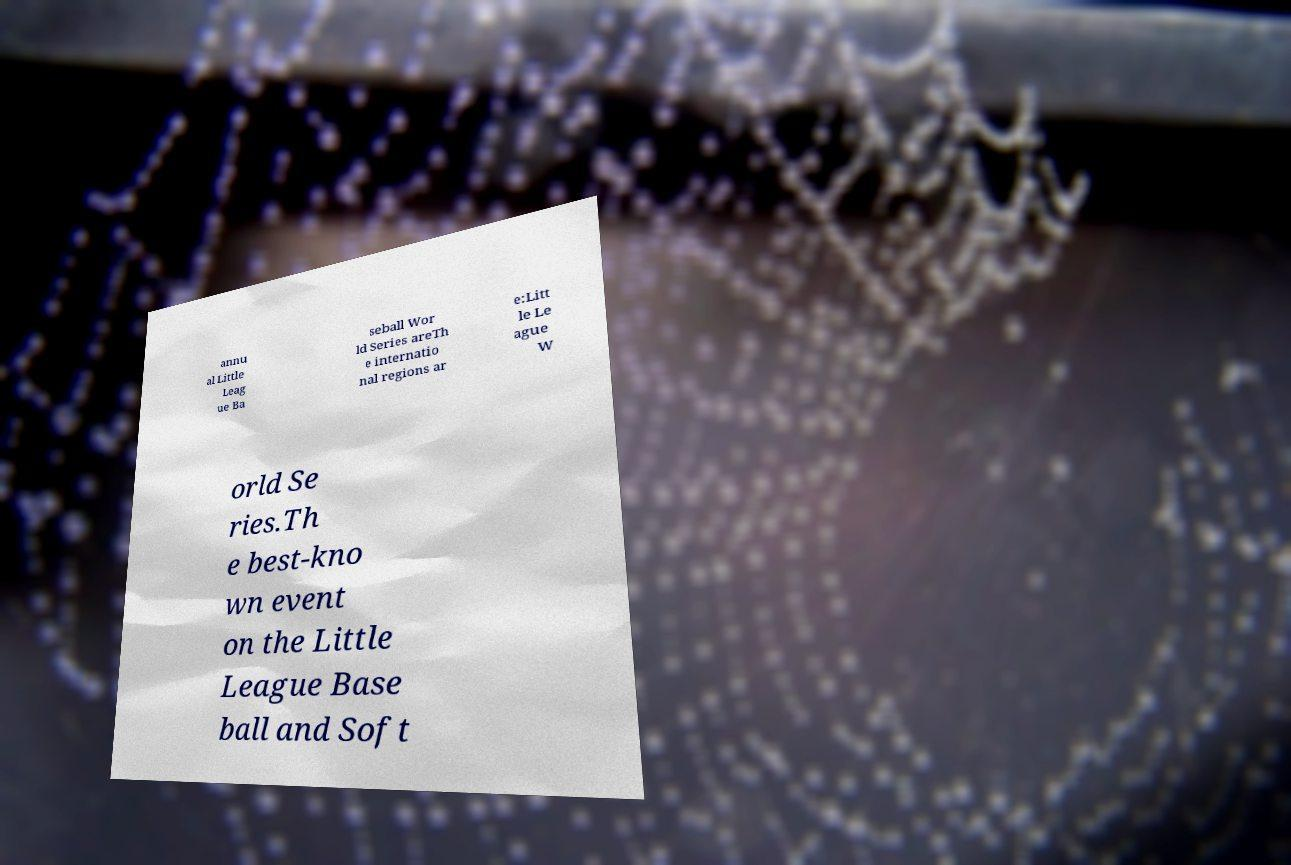Can you accurately transcribe the text from the provided image for me? annu al Little Leag ue Ba seball Wor ld Series areTh e internatio nal regions ar e:Litt le Le ague W orld Se ries.Th e best-kno wn event on the Little League Base ball and Soft 